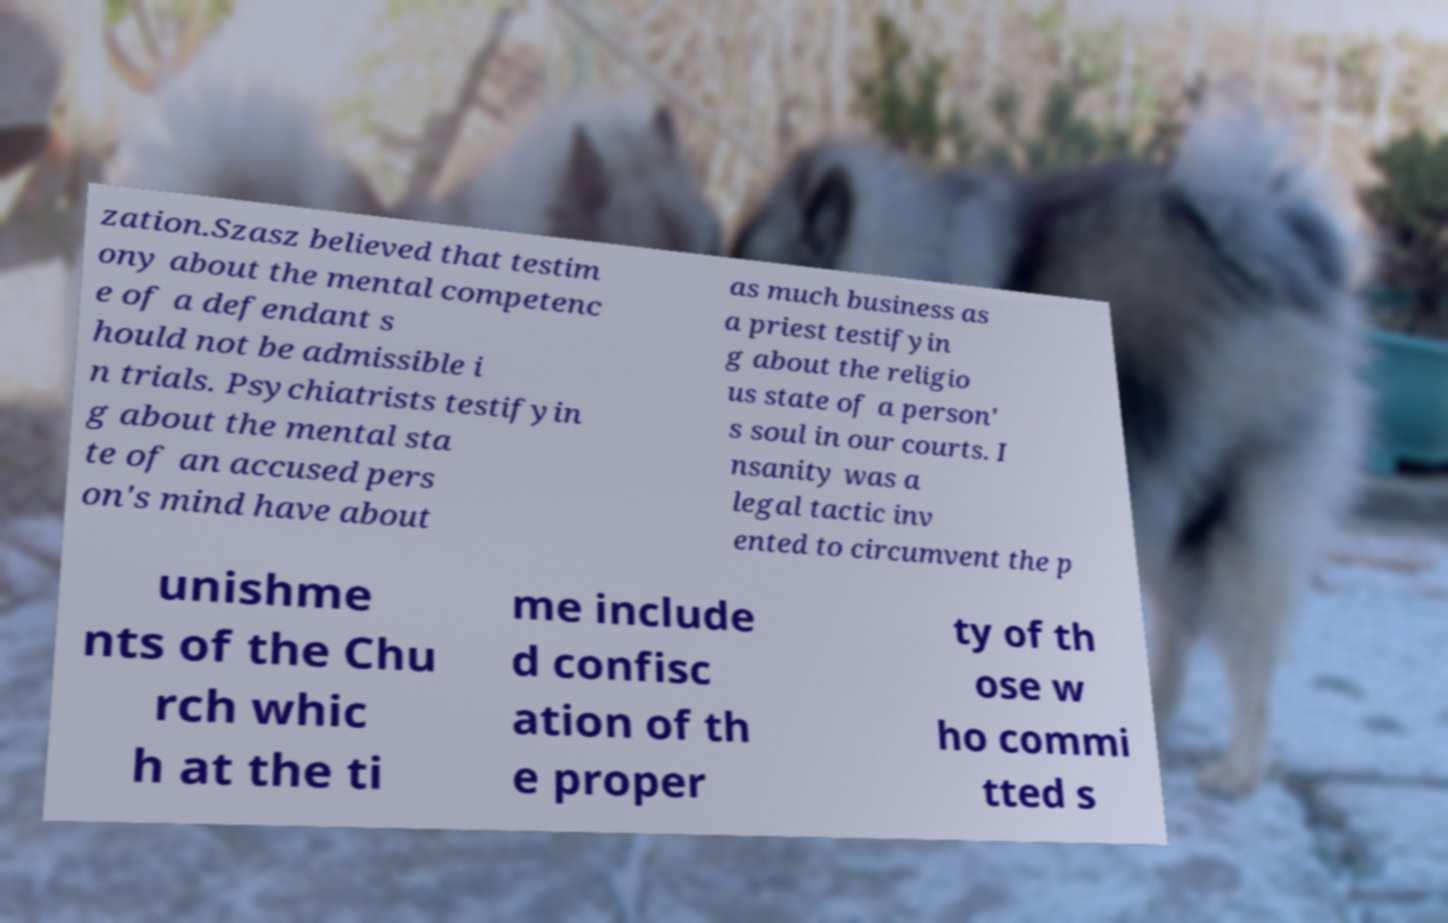What messages or text are displayed in this image? I need them in a readable, typed format. zation.Szasz believed that testim ony about the mental competenc e of a defendant s hould not be admissible i n trials. Psychiatrists testifyin g about the mental sta te of an accused pers on's mind have about as much business as a priest testifyin g about the religio us state of a person' s soul in our courts. I nsanity was a legal tactic inv ented to circumvent the p unishme nts of the Chu rch whic h at the ti me include d confisc ation of th e proper ty of th ose w ho commi tted s 